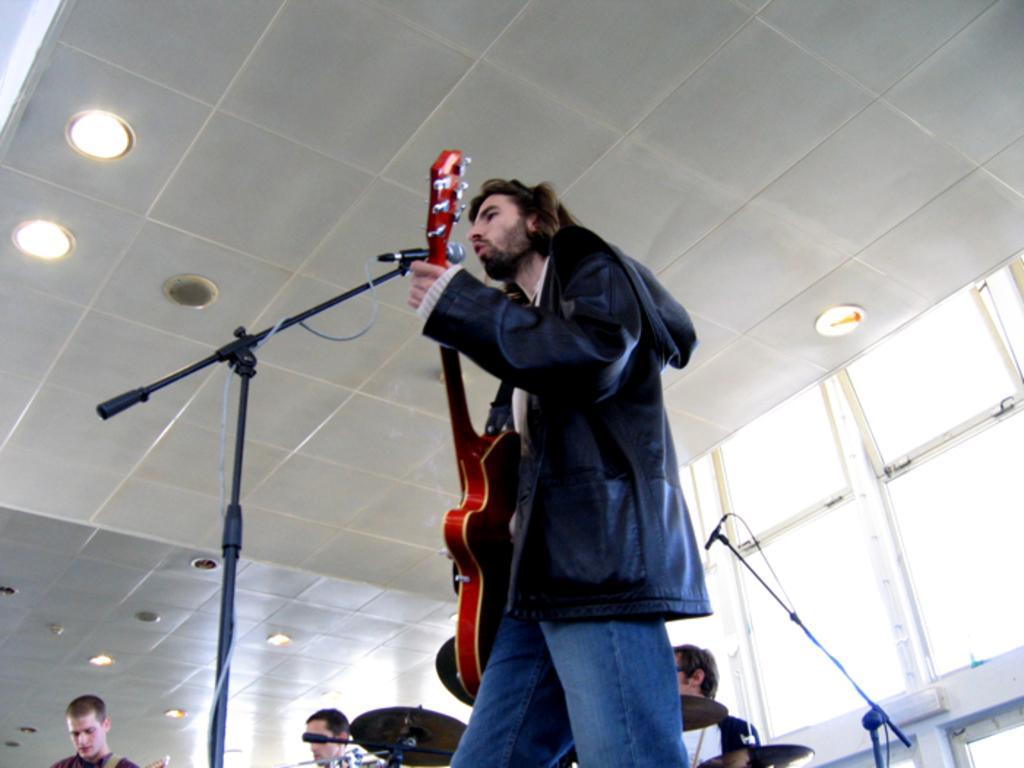Can you describe this image briefly? In this picture there is a man playing a guitar and singing. There is a mic. There are three persons at the background. There is a light. 